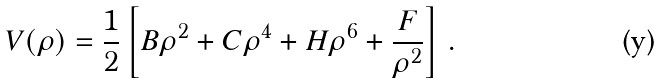<formula> <loc_0><loc_0><loc_500><loc_500>V ( \rho ) = \frac { 1 } { 2 } \left [ B \rho ^ { 2 } + C \rho ^ { 4 } + H \rho ^ { 6 } + \frac { F } { \rho ^ { 2 } } \right ] \, .</formula> 